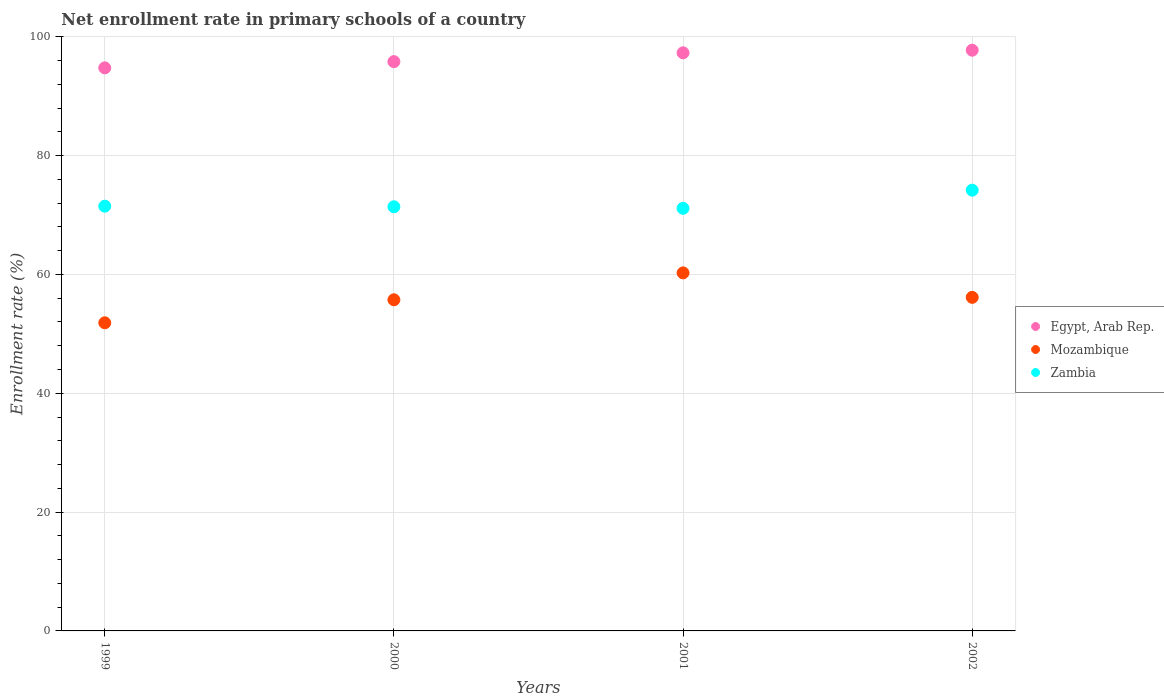How many different coloured dotlines are there?
Offer a terse response. 3. What is the enrollment rate in primary schools in Mozambique in 2001?
Ensure brevity in your answer.  60.26. Across all years, what is the maximum enrollment rate in primary schools in Zambia?
Your answer should be compact. 74.18. Across all years, what is the minimum enrollment rate in primary schools in Zambia?
Make the answer very short. 71.13. In which year was the enrollment rate in primary schools in Zambia maximum?
Offer a terse response. 2002. In which year was the enrollment rate in primary schools in Zambia minimum?
Ensure brevity in your answer.  2001. What is the total enrollment rate in primary schools in Zambia in the graph?
Give a very brief answer. 288.19. What is the difference between the enrollment rate in primary schools in Zambia in 2000 and that in 2001?
Make the answer very short. 0.26. What is the difference between the enrollment rate in primary schools in Zambia in 1999 and the enrollment rate in primary schools in Mozambique in 2000?
Make the answer very short. 15.76. What is the average enrollment rate in primary schools in Mozambique per year?
Make the answer very short. 56. In the year 1999, what is the difference between the enrollment rate in primary schools in Egypt, Arab Rep. and enrollment rate in primary schools in Mozambique?
Ensure brevity in your answer.  42.91. What is the ratio of the enrollment rate in primary schools in Egypt, Arab Rep. in 2000 to that in 2001?
Keep it short and to the point. 0.98. Is the difference between the enrollment rate in primary schools in Egypt, Arab Rep. in 2000 and 2002 greater than the difference between the enrollment rate in primary schools in Mozambique in 2000 and 2002?
Your response must be concise. No. What is the difference between the highest and the second highest enrollment rate in primary schools in Egypt, Arab Rep.?
Your answer should be very brief. 0.44. What is the difference between the highest and the lowest enrollment rate in primary schools in Mozambique?
Keep it short and to the point. 8.4. Is the sum of the enrollment rate in primary schools in Mozambique in 1999 and 2000 greater than the maximum enrollment rate in primary schools in Egypt, Arab Rep. across all years?
Provide a succinct answer. Yes. Is it the case that in every year, the sum of the enrollment rate in primary schools in Zambia and enrollment rate in primary schools in Egypt, Arab Rep.  is greater than the enrollment rate in primary schools in Mozambique?
Offer a very short reply. Yes. Does the enrollment rate in primary schools in Egypt, Arab Rep. monotonically increase over the years?
Make the answer very short. Yes. Is the enrollment rate in primary schools in Mozambique strictly greater than the enrollment rate in primary schools in Egypt, Arab Rep. over the years?
Your response must be concise. No. Is the enrollment rate in primary schools in Zambia strictly less than the enrollment rate in primary schools in Egypt, Arab Rep. over the years?
Give a very brief answer. Yes. How many dotlines are there?
Offer a very short reply. 3. How many years are there in the graph?
Provide a succinct answer. 4. What is the difference between two consecutive major ticks on the Y-axis?
Offer a terse response. 20. Are the values on the major ticks of Y-axis written in scientific E-notation?
Offer a terse response. No. Does the graph contain any zero values?
Offer a very short reply. No. Does the graph contain grids?
Your response must be concise. Yes. Where does the legend appear in the graph?
Offer a terse response. Center right. How many legend labels are there?
Provide a short and direct response. 3. What is the title of the graph?
Make the answer very short. Net enrollment rate in primary schools of a country. What is the label or title of the X-axis?
Provide a succinct answer. Years. What is the label or title of the Y-axis?
Keep it short and to the point. Enrollment rate (%). What is the Enrollment rate (%) in Egypt, Arab Rep. in 1999?
Make the answer very short. 94.77. What is the Enrollment rate (%) in Mozambique in 1999?
Give a very brief answer. 51.86. What is the Enrollment rate (%) of Zambia in 1999?
Your answer should be very brief. 71.49. What is the Enrollment rate (%) of Egypt, Arab Rep. in 2000?
Provide a short and direct response. 95.82. What is the Enrollment rate (%) in Mozambique in 2000?
Ensure brevity in your answer.  55.74. What is the Enrollment rate (%) of Zambia in 2000?
Offer a terse response. 71.39. What is the Enrollment rate (%) of Egypt, Arab Rep. in 2001?
Offer a terse response. 97.3. What is the Enrollment rate (%) of Mozambique in 2001?
Ensure brevity in your answer.  60.26. What is the Enrollment rate (%) of Zambia in 2001?
Provide a short and direct response. 71.13. What is the Enrollment rate (%) of Egypt, Arab Rep. in 2002?
Provide a succinct answer. 97.74. What is the Enrollment rate (%) in Mozambique in 2002?
Your answer should be compact. 56.14. What is the Enrollment rate (%) of Zambia in 2002?
Your answer should be very brief. 74.18. Across all years, what is the maximum Enrollment rate (%) in Egypt, Arab Rep.?
Keep it short and to the point. 97.74. Across all years, what is the maximum Enrollment rate (%) of Mozambique?
Offer a very short reply. 60.26. Across all years, what is the maximum Enrollment rate (%) in Zambia?
Your answer should be very brief. 74.18. Across all years, what is the minimum Enrollment rate (%) of Egypt, Arab Rep.?
Offer a terse response. 94.77. Across all years, what is the minimum Enrollment rate (%) in Mozambique?
Give a very brief answer. 51.86. Across all years, what is the minimum Enrollment rate (%) in Zambia?
Ensure brevity in your answer.  71.13. What is the total Enrollment rate (%) of Egypt, Arab Rep. in the graph?
Keep it short and to the point. 385.64. What is the total Enrollment rate (%) of Mozambique in the graph?
Offer a very short reply. 224. What is the total Enrollment rate (%) in Zambia in the graph?
Offer a terse response. 288.19. What is the difference between the Enrollment rate (%) of Egypt, Arab Rep. in 1999 and that in 2000?
Give a very brief answer. -1.05. What is the difference between the Enrollment rate (%) in Mozambique in 1999 and that in 2000?
Your answer should be very brief. -3.87. What is the difference between the Enrollment rate (%) of Zambia in 1999 and that in 2000?
Provide a short and direct response. 0.1. What is the difference between the Enrollment rate (%) of Egypt, Arab Rep. in 1999 and that in 2001?
Keep it short and to the point. -2.53. What is the difference between the Enrollment rate (%) in Mozambique in 1999 and that in 2001?
Offer a very short reply. -8.4. What is the difference between the Enrollment rate (%) in Zambia in 1999 and that in 2001?
Offer a terse response. 0.36. What is the difference between the Enrollment rate (%) in Egypt, Arab Rep. in 1999 and that in 2002?
Make the answer very short. -2.97. What is the difference between the Enrollment rate (%) in Mozambique in 1999 and that in 2002?
Your response must be concise. -4.28. What is the difference between the Enrollment rate (%) in Zambia in 1999 and that in 2002?
Provide a succinct answer. -2.69. What is the difference between the Enrollment rate (%) of Egypt, Arab Rep. in 2000 and that in 2001?
Give a very brief answer. -1.48. What is the difference between the Enrollment rate (%) in Mozambique in 2000 and that in 2001?
Ensure brevity in your answer.  -4.53. What is the difference between the Enrollment rate (%) in Zambia in 2000 and that in 2001?
Offer a very short reply. 0.26. What is the difference between the Enrollment rate (%) in Egypt, Arab Rep. in 2000 and that in 2002?
Keep it short and to the point. -1.92. What is the difference between the Enrollment rate (%) in Mozambique in 2000 and that in 2002?
Keep it short and to the point. -0.41. What is the difference between the Enrollment rate (%) of Zambia in 2000 and that in 2002?
Your answer should be compact. -2.79. What is the difference between the Enrollment rate (%) of Egypt, Arab Rep. in 2001 and that in 2002?
Your answer should be very brief. -0.44. What is the difference between the Enrollment rate (%) of Mozambique in 2001 and that in 2002?
Provide a succinct answer. 4.12. What is the difference between the Enrollment rate (%) in Zambia in 2001 and that in 2002?
Provide a succinct answer. -3.05. What is the difference between the Enrollment rate (%) of Egypt, Arab Rep. in 1999 and the Enrollment rate (%) of Mozambique in 2000?
Offer a terse response. 39.04. What is the difference between the Enrollment rate (%) of Egypt, Arab Rep. in 1999 and the Enrollment rate (%) of Zambia in 2000?
Make the answer very short. 23.38. What is the difference between the Enrollment rate (%) in Mozambique in 1999 and the Enrollment rate (%) in Zambia in 2000?
Your response must be concise. -19.53. What is the difference between the Enrollment rate (%) in Egypt, Arab Rep. in 1999 and the Enrollment rate (%) in Mozambique in 2001?
Keep it short and to the point. 34.51. What is the difference between the Enrollment rate (%) of Egypt, Arab Rep. in 1999 and the Enrollment rate (%) of Zambia in 2001?
Give a very brief answer. 23.64. What is the difference between the Enrollment rate (%) in Mozambique in 1999 and the Enrollment rate (%) in Zambia in 2001?
Provide a succinct answer. -19.27. What is the difference between the Enrollment rate (%) in Egypt, Arab Rep. in 1999 and the Enrollment rate (%) in Mozambique in 2002?
Your answer should be compact. 38.63. What is the difference between the Enrollment rate (%) of Egypt, Arab Rep. in 1999 and the Enrollment rate (%) of Zambia in 2002?
Give a very brief answer. 20.59. What is the difference between the Enrollment rate (%) of Mozambique in 1999 and the Enrollment rate (%) of Zambia in 2002?
Offer a terse response. -22.32. What is the difference between the Enrollment rate (%) in Egypt, Arab Rep. in 2000 and the Enrollment rate (%) in Mozambique in 2001?
Ensure brevity in your answer.  35.56. What is the difference between the Enrollment rate (%) of Egypt, Arab Rep. in 2000 and the Enrollment rate (%) of Zambia in 2001?
Ensure brevity in your answer.  24.69. What is the difference between the Enrollment rate (%) in Mozambique in 2000 and the Enrollment rate (%) in Zambia in 2001?
Your response must be concise. -15.4. What is the difference between the Enrollment rate (%) in Egypt, Arab Rep. in 2000 and the Enrollment rate (%) in Mozambique in 2002?
Ensure brevity in your answer.  39.68. What is the difference between the Enrollment rate (%) of Egypt, Arab Rep. in 2000 and the Enrollment rate (%) of Zambia in 2002?
Give a very brief answer. 21.64. What is the difference between the Enrollment rate (%) of Mozambique in 2000 and the Enrollment rate (%) of Zambia in 2002?
Provide a succinct answer. -18.45. What is the difference between the Enrollment rate (%) of Egypt, Arab Rep. in 2001 and the Enrollment rate (%) of Mozambique in 2002?
Your response must be concise. 41.16. What is the difference between the Enrollment rate (%) in Egypt, Arab Rep. in 2001 and the Enrollment rate (%) in Zambia in 2002?
Keep it short and to the point. 23.12. What is the difference between the Enrollment rate (%) of Mozambique in 2001 and the Enrollment rate (%) of Zambia in 2002?
Make the answer very short. -13.92. What is the average Enrollment rate (%) in Egypt, Arab Rep. per year?
Your answer should be very brief. 96.41. What is the average Enrollment rate (%) of Mozambique per year?
Keep it short and to the point. 56. What is the average Enrollment rate (%) of Zambia per year?
Your answer should be compact. 72.05. In the year 1999, what is the difference between the Enrollment rate (%) of Egypt, Arab Rep. and Enrollment rate (%) of Mozambique?
Keep it short and to the point. 42.91. In the year 1999, what is the difference between the Enrollment rate (%) of Egypt, Arab Rep. and Enrollment rate (%) of Zambia?
Give a very brief answer. 23.28. In the year 1999, what is the difference between the Enrollment rate (%) of Mozambique and Enrollment rate (%) of Zambia?
Your answer should be compact. -19.63. In the year 2000, what is the difference between the Enrollment rate (%) of Egypt, Arab Rep. and Enrollment rate (%) of Mozambique?
Offer a very short reply. 40.08. In the year 2000, what is the difference between the Enrollment rate (%) of Egypt, Arab Rep. and Enrollment rate (%) of Zambia?
Keep it short and to the point. 24.43. In the year 2000, what is the difference between the Enrollment rate (%) in Mozambique and Enrollment rate (%) in Zambia?
Provide a succinct answer. -15.65. In the year 2001, what is the difference between the Enrollment rate (%) in Egypt, Arab Rep. and Enrollment rate (%) in Mozambique?
Offer a very short reply. 37.04. In the year 2001, what is the difference between the Enrollment rate (%) in Egypt, Arab Rep. and Enrollment rate (%) in Zambia?
Keep it short and to the point. 26.17. In the year 2001, what is the difference between the Enrollment rate (%) in Mozambique and Enrollment rate (%) in Zambia?
Provide a succinct answer. -10.87. In the year 2002, what is the difference between the Enrollment rate (%) of Egypt, Arab Rep. and Enrollment rate (%) of Mozambique?
Your answer should be compact. 41.6. In the year 2002, what is the difference between the Enrollment rate (%) of Egypt, Arab Rep. and Enrollment rate (%) of Zambia?
Offer a terse response. 23.56. In the year 2002, what is the difference between the Enrollment rate (%) in Mozambique and Enrollment rate (%) in Zambia?
Make the answer very short. -18.04. What is the ratio of the Enrollment rate (%) of Egypt, Arab Rep. in 1999 to that in 2000?
Give a very brief answer. 0.99. What is the ratio of the Enrollment rate (%) of Mozambique in 1999 to that in 2000?
Your answer should be compact. 0.93. What is the ratio of the Enrollment rate (%) of Zambia in 1999 to that in 2000?
Offer a very short reply. 1. What is the ratio of the Enrollment rate (%) in Mozambique in 1999 to that in 2001?
Your answer should be compact. 0.86. What is the ratio of the Enrollment rate (%) of Zambia in 1999 to that in 2001?
Keep it short and to the point. 1.01. What is the ratio of the Enrollment rate (%) in Egypt, Arab Rep. in 1999 to that in 2002?
Make the answer very short. 0.97. What is the ratio of the Enrollment rate (%) in Mozambique in 1999 to that in 2002?
Your answer should be very brief. 0.92. What is the ratio of the Enrollment rate (%) in Zambia in 1999 to that in 2002?
Your answer should be compact. 0.96. What is the ratio of the Enrollment rate (%) in Egypt, Arab Rep. in 2000 to that in 2001?
Keep it short and to the point. 0.98. What is the ratio of the Enrollment rate (%) of Mozambique in 2000 to that in 2001?
Provide a short and direct response. 0.92. What is the ratio of the Enrollment rate (%) of Egypt, Arab Rep. in 2000 to that in 2002?
Offer a very short reply. 0.98. What is the ratio of the Enrollment rate (%) of Zambia in 2000 to that in 2002?
Your answer should be very brief. 0.96. What is the ratio of the Enrollment rate (%) in Mozambique in 2001 to that in 2002?
Your response must be concise. 1.07. What is the ratio of the Enrollment rate (%) of Zambia in 2001 to that in 2002?
Offer a terse response. 0.96. What is the difference between the highest and the second highest Enrollment rate (%) of Egypt, Arab Rep.?
Make the answer very short. 0.44. What is the difference between the highest and the second highest Enrollment rate (%) in Mozambique?
Give a very brief answer. 4.12. What is the difference between the highest and the second highest Enrollment rate (%) of Zambia?
Keep it short and to the point. 2.69. What is the difference between the highest and the lowest Enrollment rate (%) of Egypt, Arab Rep.?
Your answer should be compact. 2.97. What is the difference between the highest and the lowest Enrollment rate (%) in Mozambique?
Your response must be concise. 8.4. What is the difference between the highest and the lowest Enrollment rate (%) of Zambia?
Keep it short and to the point. 3.05. 